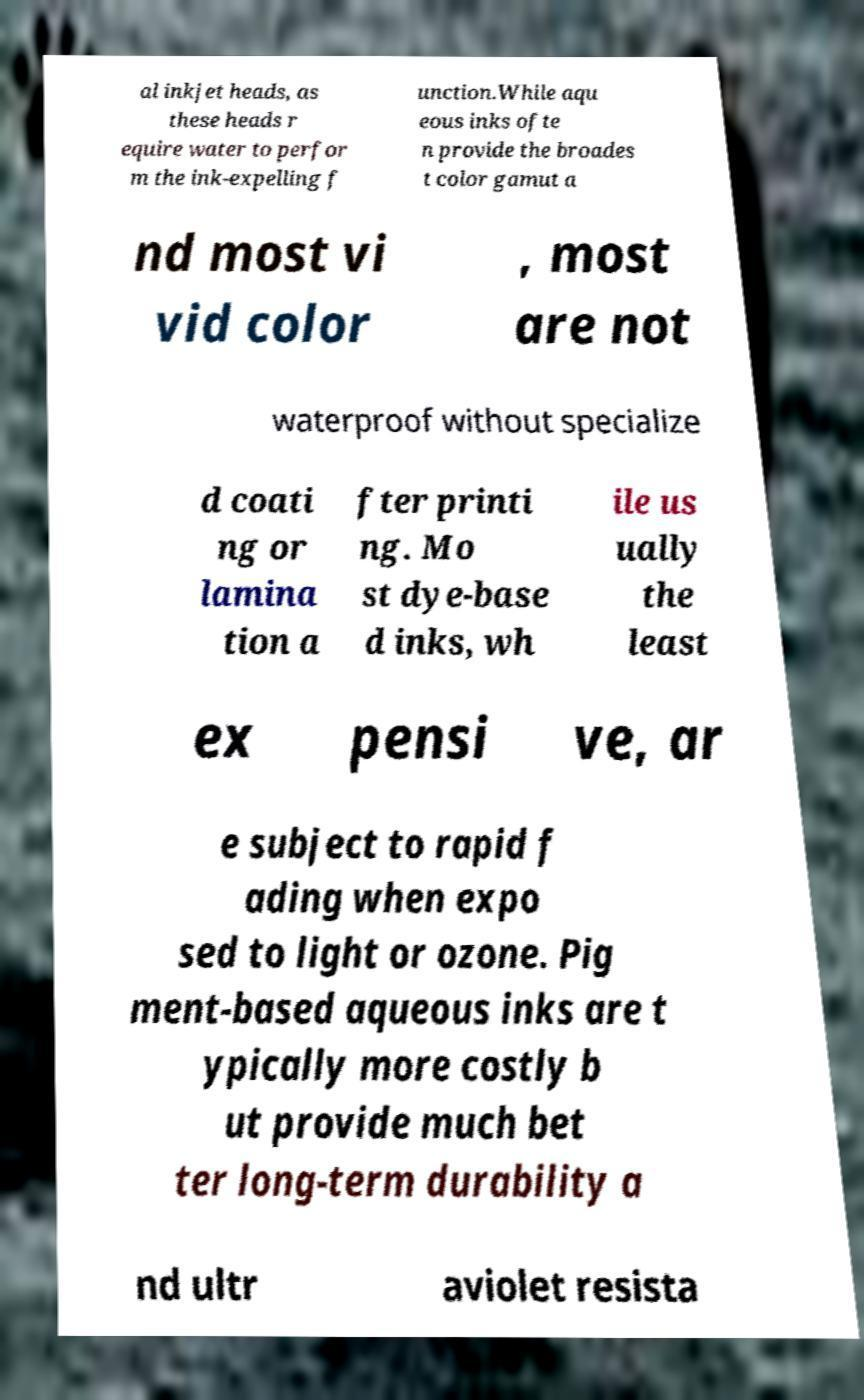What messages or text are displayed in this image? I need them in a readable, typed format. al inkjet heads, as these heads r equire water to perfor m the ink-expelling f unction.While aqu eous inks ofte n provide the broades t color gamut a nd most vi vid color , most are not waterproof without specialize d coati ng or lamina tion a fter printi ng. Mo st dye-base d inks, wh ile us ually the least ex pensi ve, ar e subject to rapid f ading when expo sed to light or ozone. Pig ment-based aqueous inks are t ypically more costly b ut provide much bet ter long-term durability a nd ultr aviolet resista 